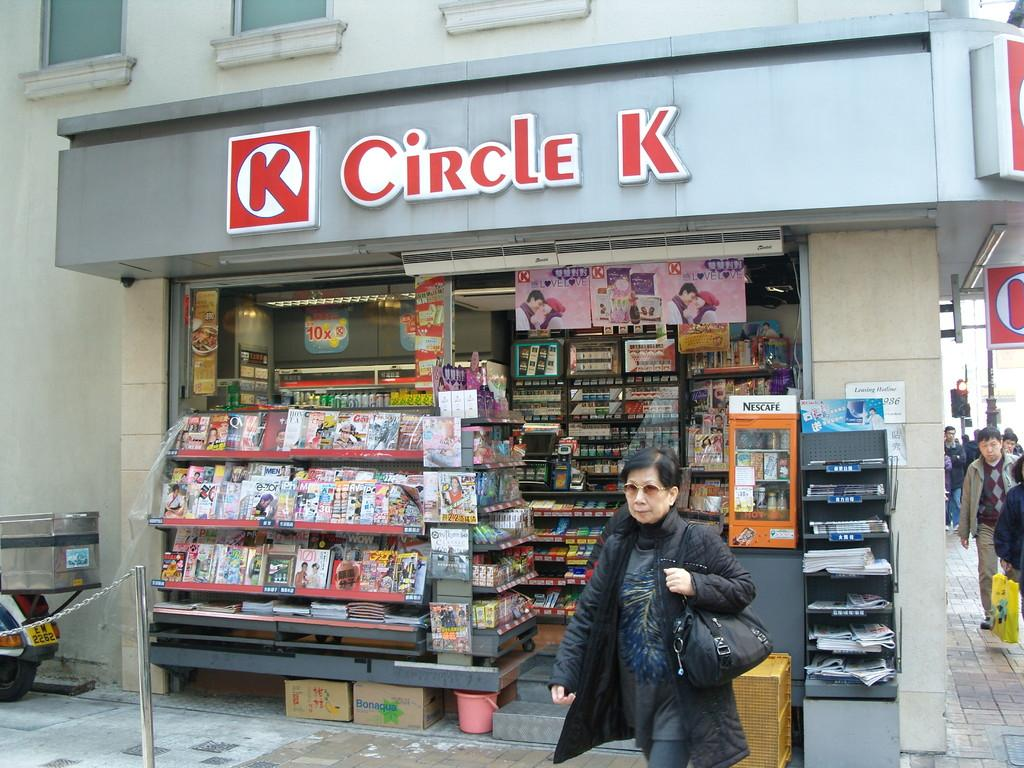<image>
Relay a brief, clear account of the picture shown. A woman walks away from the entrance of a Circle K store. 